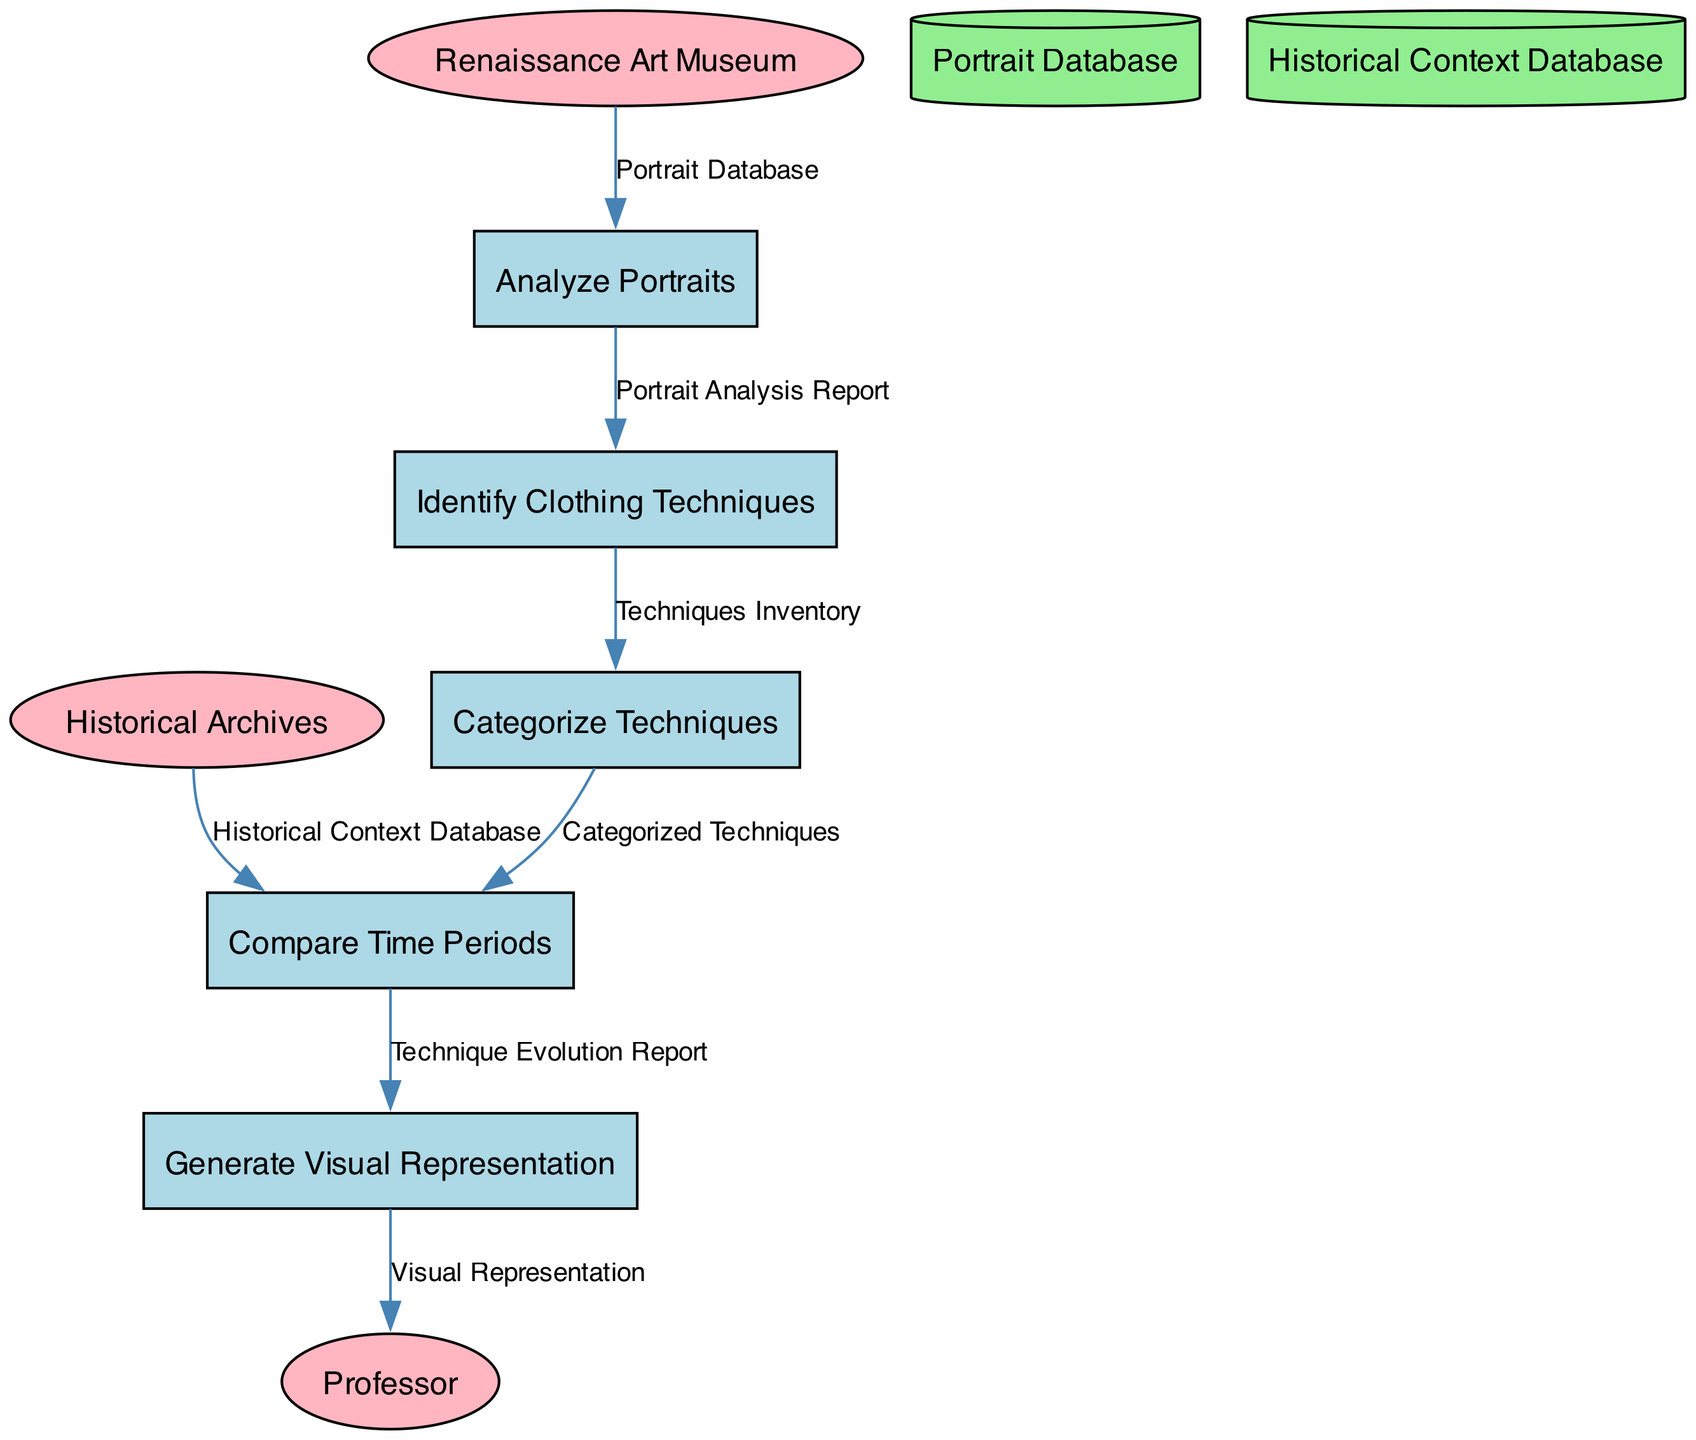What is the first process in the diagram? The first process in the diagram is labeled "Analyze Portraits," as it is the starting point of the flow and has the ID of "1."
Answer: Analyze Portraits How many data stores are present in the diagram? The diagram contains two data stores: "Portrait Database" and "Historical Context Database." Thus, the total count is two.
Answer: 2 What is the output of the process "Identify Clothing Techniques"? The output of the "Identify Clothing Techniques" process is the "Techniques Inventory," as specified in the outputs of that process.
Answer: Techniques Inventory Which external entity provides data to "Analyze Portraits"? The external entity providing data to "Analyze Portraits" is the "Renaissance Art Museum," which supplies the "Portrait Database."
Answer: Renaissance Art Museum What are the two inputs for the process "Compare Time Periods"? The two inputs for the "Compare Time Periods" process are "Categorized Techniques" and "Historical Context Database," both of which are required to perform the comparison.
Answer: Categorized Techniques, Historical Context Database Which process generates the final output of the diagram? The process that generates the final output of the diagram is "Generate Visual Representation," leading to the output of "Visual Representation."
Answer: Generate Visual Representation What is connected to the output of "Compare Time Periods"? The output of "Compare Time Periods" is connected to the input of "Generate Visual Representation," showing the flow from the evolution report to visual representation creation.
Answer: Generate Visual Representation How does the flow of data proceed from "Identify Clothing Techniques" to "Categorize Techniques"? The data flows from "Identify Clothing Techniques" to "Categorize Techniques" through the output "Techniques Inventory," which serves as the required input for the categorization process.
Answer: Techniques Inventory 